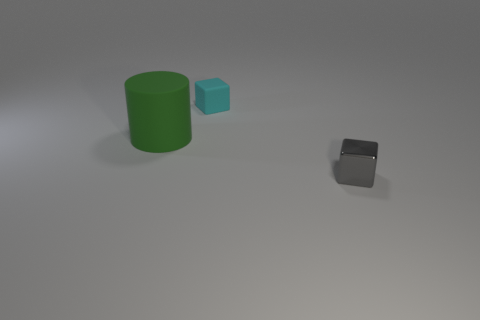Is there any other thing that is the same shape as the gray object?
Provide a short and direct response. Yes. What is the shape of the small object to the left of the cube that is in front of the thing that is behind the large object?
Keep it short and to the point. Cube. The tiny gray object has what shape?
Your response must be concise. Cube. What is the color of the rubber object behind the large rubber object?
Provide a succinct answer. Cyan. Is the size of the thing that is to the left of the cyan thing the same as the tiny gray metallic thing?
Your response must be concise. No. There is a gray thing that is the same shape as the small cyan matte object; what size is it?
Provide a succinct answer. Small. Is there anything else that has the same size as the cyan matte thing?
Give a very brief answer. Yes. Is the tiny cyan rubber thing the same shape as the large green matte object?
Your response must be concise. No. Are there fewer small blocks that are behind the large rubber cylinder than small objects that are to the left of the tiny gray shiny block?
Your answer should be very brief. No. There is a tiny gray metal cube; how many big cylinders are behind it?
Make the answer very short. 1. 